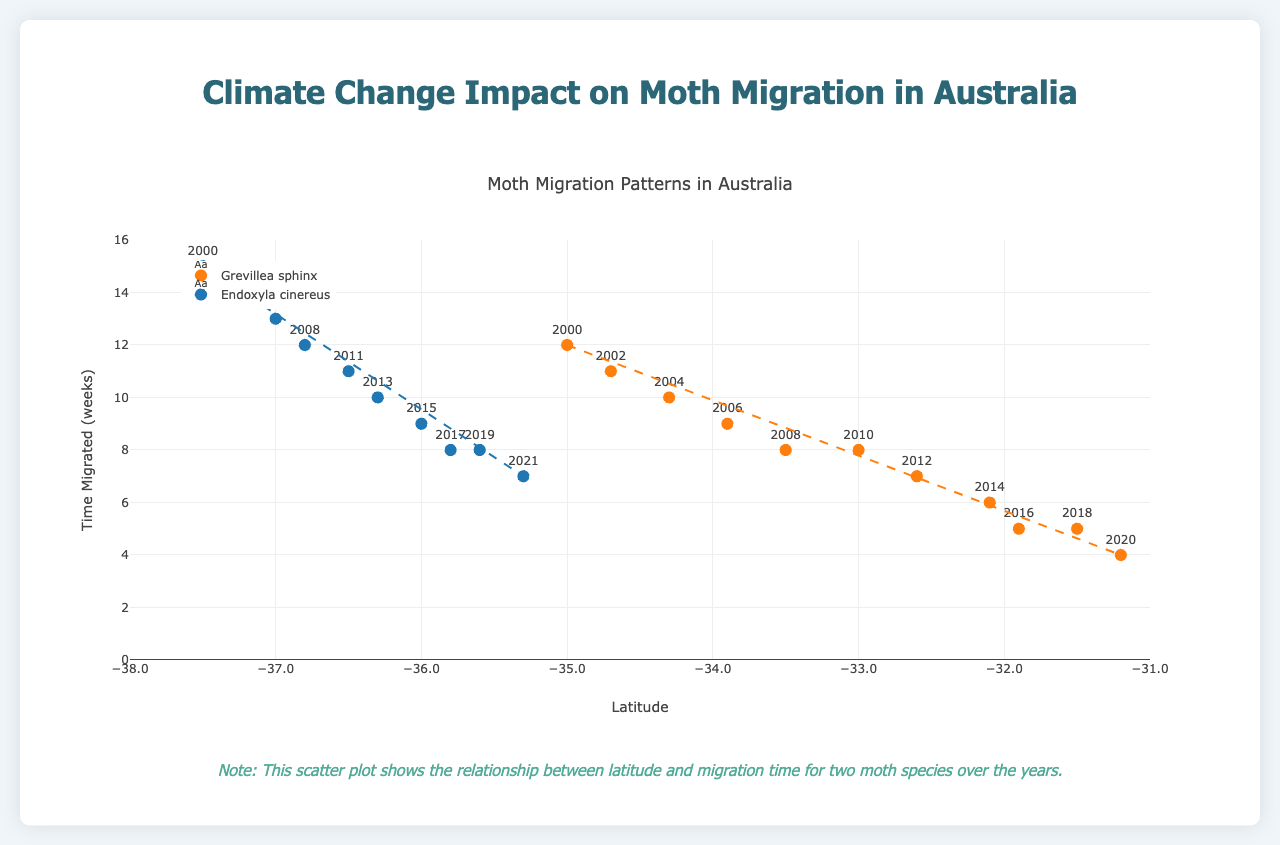What is the title of the figure? The title of the figure is displayed at the top of the plot. It reads "Moth Migration Patterns in Australia".
Answer: Moth Migration Patterns in Australia What is the range of the y-axis (Time Migrated)? The range of the y-axis is indicated by the values labeled on the axis, from 0 to 16 weeks.
Answer: 0 to 16 weeks Which species of moth has the highest latitude recorded? By looking at the plotted points and the corresponding text labels, we see that the highest latitude, which is -31.2, is recorded for Grevillea sphinx in the year 2020.
Answer: Grevillea sphinx How does the migration time of Grevillea sphinx change over the years? The migration time of Grevillea sphinx gradually decreases over the years from 12 weeks in 2000 to 4 weeks in 2020, as indicated by the trend line and data points.
Answer: Decreases In which month is the migration of Endoxyla cinereus recorded in 2021? The month is indicated by the "Month" data label associated with the plotted point for 2021, which is July.
Answer: July Compare the time migrated between Grevillea sphinx and Endoxyla cinereus in the year 2008. Referencing the plot, in 2008, Grevillea sphinx takes 8 weeks and Endoxyla cinereus takes 12 weeks to migrate.
Answer: Grevillea sphinx: 8 weeks, Endoxyla cinereus: 12 weeks What visible trend can be noted about the latitudes of Endoxyla cinereus over the years? The latitudes of Endoxyla cinereus gradually increase (become less negative) over the years, from -37.5 in 2000 to -35.3 in 2021, indicated by the trend line.
Answer: Gradually increase How does the migration time of Grevillea sphinx in July compare to that in August of any year depicted? For Grevillea sphinx, in July, the migration times are 6 weeks (2014) and 5 weeks (2016). In August, it's 5 weeks (2018) and 4 weeks (2020). This indicates migration times are shorter in August than in July.
Answer: Shorter in August Estimate the migration time for Endoxyla cinereus at latitude -35.5 based on the trend line. Referencing the trend line for Endoxyla cinereus, a latitude of -35.5 corresponds to an estimated migration time of approximately 8 weeks.
Answer: Approximately 8 weeks 